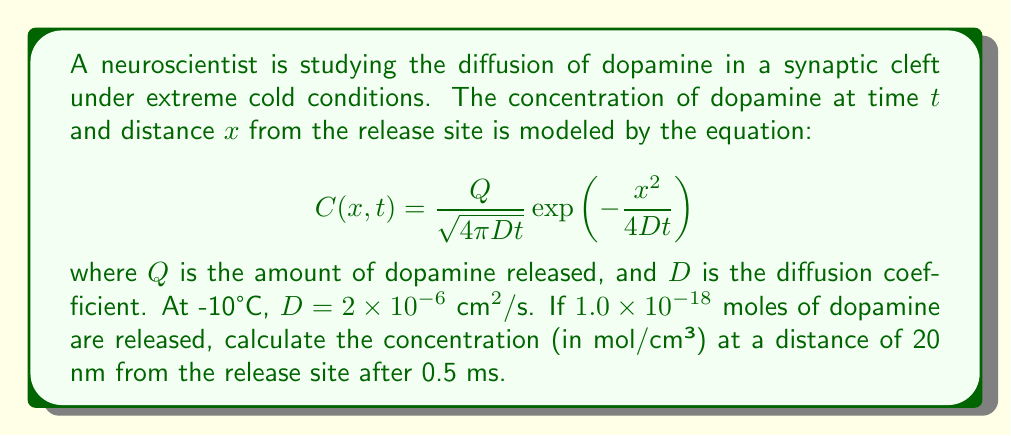Give your solution to this math problem. Let's approach this step-by-step:

1) First, we need to identify the given values:
   $Q = 1.0 \times 10^{-18}$ moles
   $D = 2 \times 10^{-6} \text{ cm}^2/\text{s}$
   $x = 20 \text{ nm} = 2 \times 10^{-6} \text{ cm}$
   $t = 0.5 \text{ ms} = 5 \times 10^{-4} \text{ s}$

2) Now, let's substitute these values into the equation:

   $$C(x,t) = \frac{1.0 \times 10^{-18}}{\sqrt{4\pi (2 \times 10^{-6})(5 \times 10^{-4})}} \exp\left(-\frac{(2 \times 10^{-6})^2}{4(2 \times 10^{-6})(5 \times 10^{-4})}\right)$$

3) Let's simplify the expression under the square root in the denominator:
   $4\pi (2 \times 10^{-6})(5 \times 10^{-4}) = 4\pi \times 10^{-9} = 1.26 \times 10^{-8}$

4) Now, let's simplify the exponent:
   $\frac{(2 \times 10^{-6})^2}{4(2 \times 10^{-6})(5 \times 10^{-4})} = \frac{4 \times 10^{-12}}{4 \times 10^{-9}} = 10^{-3} = 0.001$

5) Our equation now looks like:

   $$C(x,t) = \frac{1.0 \times 10^{-18}}{\sqrt{1.26 \times 10^{-8}}} \exp(-0.001)$$

6) Simplify:
   $\frac{1.0 \times 10^{-18}}{\sqrt{1.26 \times 10^{-8}}} = \frac{1.0 \times 10^{-18}}{3.55 \times 10^{-5}} = 2.82 \times 10^{-14}$

7) Calculate $\exp(-0.001) \approx 0.999$

8) Therefore, the final concentration is:
   $C(x,t) = (2.82 \times 10^{-14})(0.999) = 2.81 \times 10^{-14} \text{ mol/cm}^3$
Answer: $2.81 \times 10^{-14} \text{ mol/cm}^3$ 